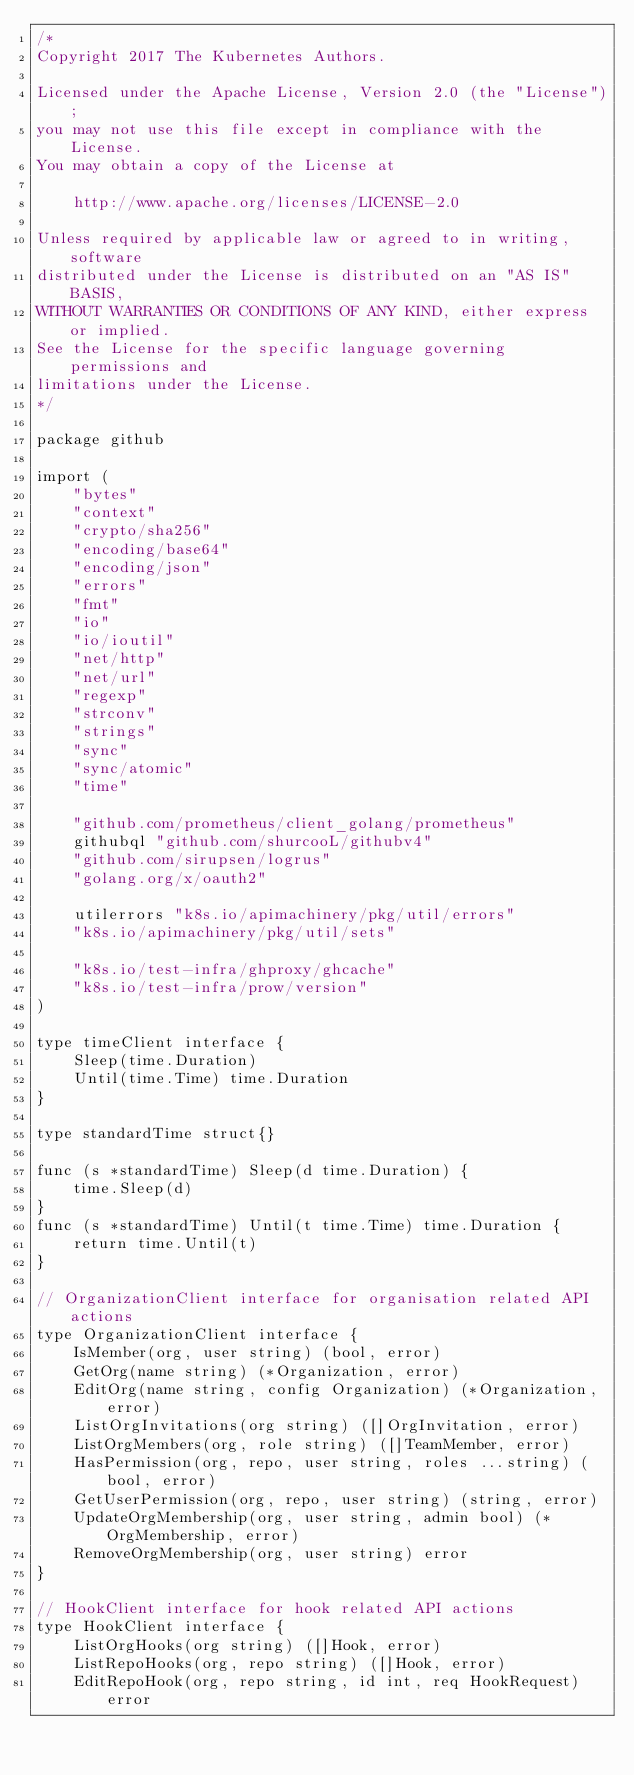Convert code to text. <code><loc_0><loc_0><loc_500><loc_500><_Go_>/*
Copyright 2017 The Kubernetes Authors.

Licensed under the Apache License, Version 2.0 (the "License");
you may not use this file except in compliance with the License.
You may obtain a copy of the License at

    http://www.apache.org/licenses/LICENSE-2.0

Unless required by applicable law or agreed to in writing, software
distributed under the License is distributed on an "AS IS" BASIS,
WITHOUT WARRANTIES OR CONDITIONS OF ANY KIND, either express or implied.
See the License for the specific language governing permissions and
limitations under the License.
*/

package github

import (
	"bytes"
	"context"
	"crypto/sha256"
	"encoding/base64"
	"encoding/json"
	"errors"
	"fmt"
	"io"
	"io/ioutil"
	"net/http"
	"net/url"
	"regexp"
	"strconv"
	"strings"
	"sync"
	"sync/atomic"
	"time"

	"github.com/prometheus/client_golang/prometheus"
	githubql "github.com/shurcooL/githubv4"
	"github.com/sirupsen/logrus"
	"golang.org/x/oauth2"

	utilerrors "k8s.io/apimachinery/pkg/util/errors"
	"k8s.io/apimachinery/pkg/util/sets"

	"k8s.io/test-infra/ghproxy/ghcache"
	"k8s.io/test-infra/prow/version"
)

type timeClient interface {
	Sleep(time.Duration)
	Until(time.Time) time.Duration
}

type standardTime struct{}

func (s *standardTime) Sleep(d time.Duration) {
	time.Sleep(d)
}
func (s *standardTime) Until(t time.Time) time.Duration {
	return time.Until(t)
}

// OrganizationClient interface for organisation related API actions
type OrganizationClient interface {
	IsMember(org, user string) (bool, error)
	GetOrg(name string) (*Organization, error)
	EditOrg(name string, config Organization) (*Organization, error)
	ListOrgInvitations(org string) ([]OrgInvitation, error)
	ListOrgMembers(org, role string) ([]TeamMember, error)
	HasPermission(org, repo, user string, roles ...string) (bool, error)
	GetUserPermission(org, repo, user string) (string, error)
	UpdateOrgMembership(org, user string, admin bool) (*OrgMembership, error)
	RemoveOrgMembership(org, user string) error
}

// HookClient interface for hook related API actions
type HookClient interface {
	ListOrgHooks(org string) ([]Hook, error)
	ListRepoHooks(org, repo string) ([]Hook, error)
	EditRepoHook(org, repo string, id int, req HookRequest) error</code> 